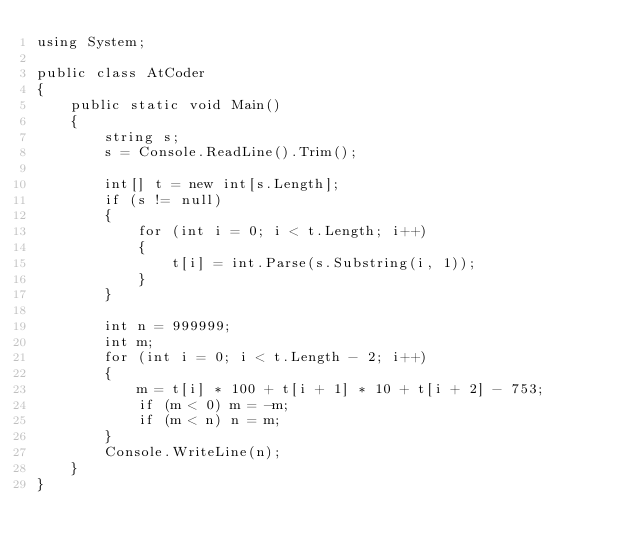Convert code to text. <code><loc_0><loc_0><loc_500><loc_500><_C#_>using System;

public class AtCoder
{
    public static void Main()
    {
        string s;
        s = Console.ReadLine().Trim();

        int[] t = new int[s.Length];
        if (s != null)
        {
            for (int i = 0; i < t.Length; i++)
            {
                t[i] = int.Parse(s.Substring(i, 1));
            }
        }

        int n = 999999;
        int m;
        for (int i = 0; i < t.Length - 2; i++)
        {
            m = t[i] * 100 + t[i + 1] * 10 + t[i + 2] - 753;
            if (m < 0) m = -m;
            if (m < n) n = m;
        }
        Console.WriteLine(n);
    }
}
</code> 